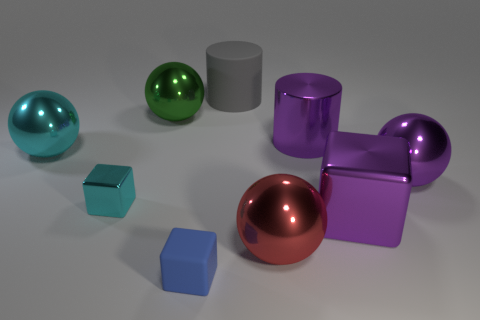Subtract all purple shiny blocks. How many blocks are left? 2 Subtract all cyan balls. How many balls are left? 3 Subtract 1 blocks. How many blocks are left? 2 Add 1 blocks. How many objects exist? 10 Subtract all spheres. How many objects are left? 5 Subtract all purple spheres. Subtract all green cylinders. How many spheres are left? 3 Subtract all large red rubber objects. Subtract all tiny things. How many objects are left? 7 Add 8 gray matte things. How many gray matte things are left? 9 Add 6 matte blocks. How many matte blocks exist? 7 Subtract 0 yellow blocks. How many objects are left? 9 